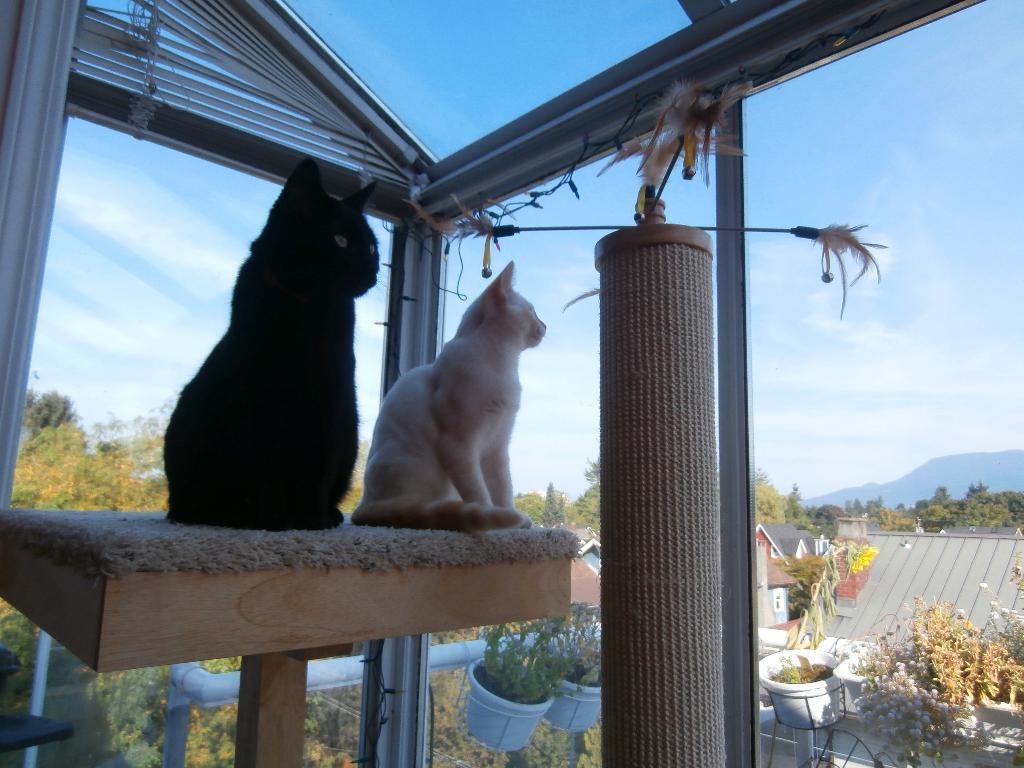In one or two sentences, can you explain what this image depicts? In this image there are two cats sat on a stand are watching houses and trees from a glass door. 